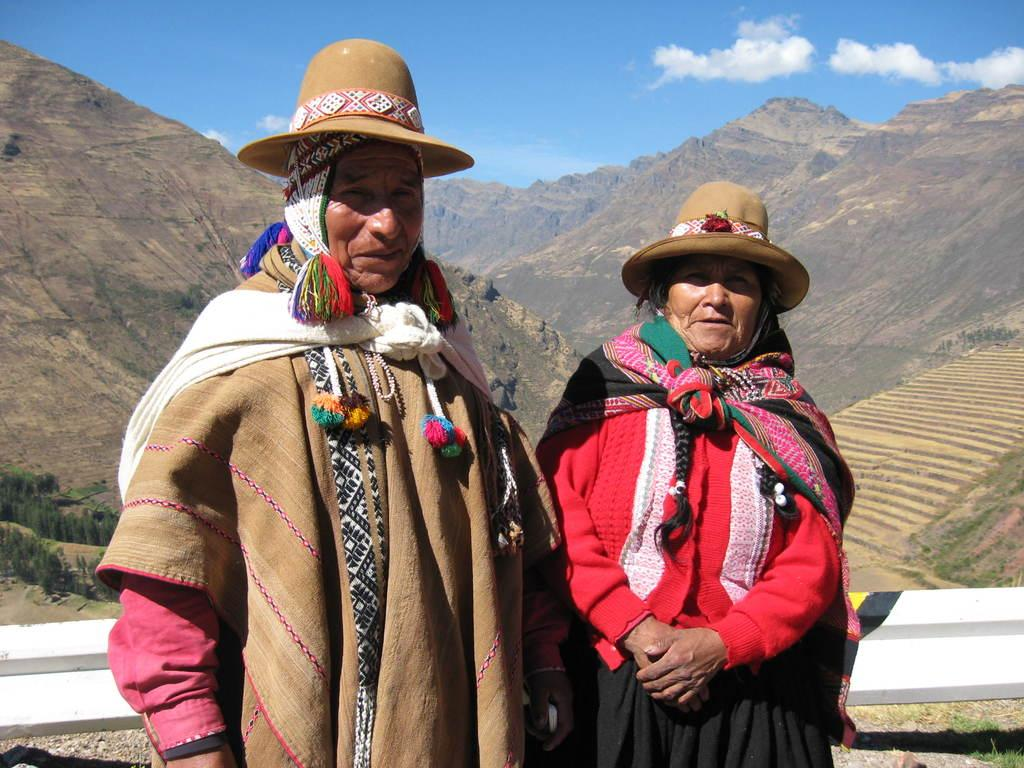Who is present in the image? There is a man and a woman in the image. What are the man and the woman wearing on their heads? Both the man and the woman are wearing caps. What type of landscape can be seen in the image? Hills are visible in the image. How would you describe the sky in the image? The sky is blue and cloudy. What type of vegetation is present in the image? There are trees in the image. What type of disease is affecting the trees in the image? There is no indication of any disease affecting the trees in the image; they appear healthy. Can you tell me how many hands are visible in the image? There is no mention of hands in the image; it only features a man and a woman wearing caps. 